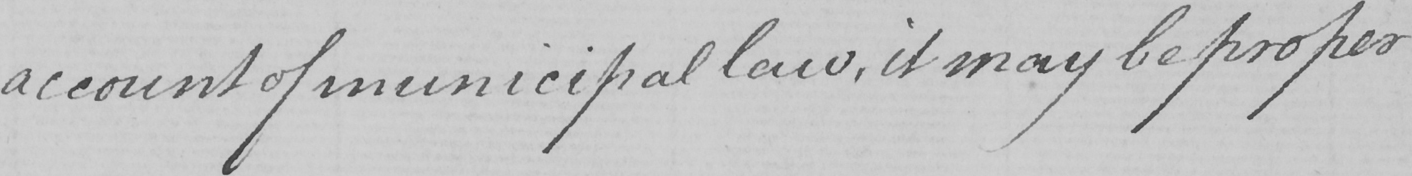What text is written in this handwritten line? account of municipal law , it may be proper 